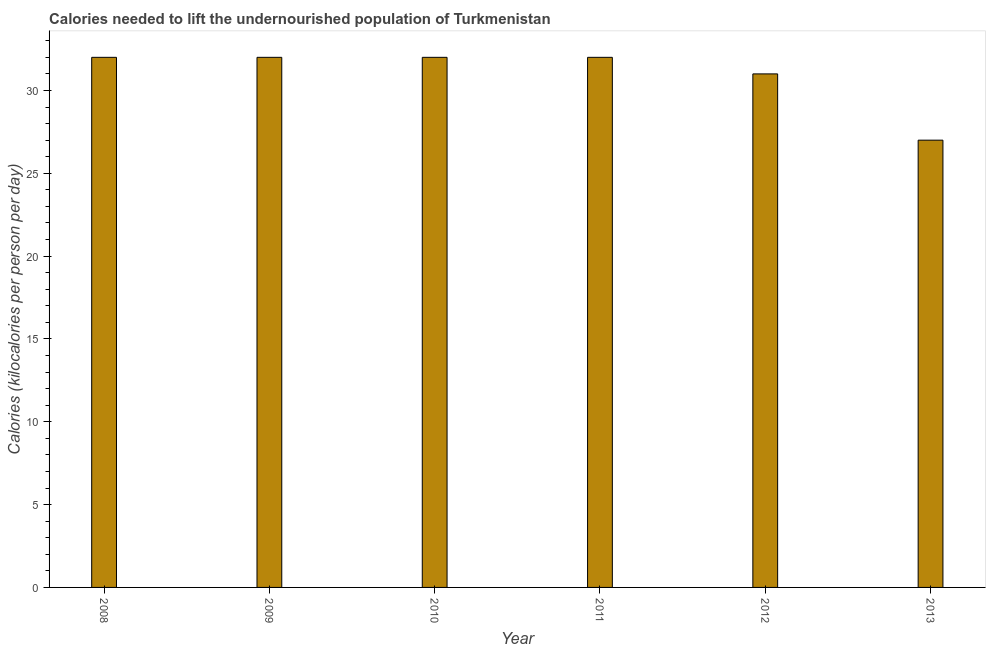Does the graph contain any zero values?
Ensure brevity in your answer.  No. What is the title of the graph?
Keep it short and to the point. Calories needed to lift the undernourished population of Turkmenistan. What is the label or title of the X-axis?
Give a very brief answer. Year. What is the label or title of the Y-axis?
Your answer should be compact. Calories (kilocalories per person per day). Across all years, what is the minimum depth of food deficit?
Your answer should be compact. 27. What is the sum of the depth of food deficit?
Offer a terse response. 186. What is the difference between the depth of food deficit in 2010 and 2011?
Your answer should be very brief. 0. What is the average depth of food deficit per year?
Keep it short and to the point. 31. Do a majority of the years between 2011 and 2012 (inclusive) have depth of food deficit greater than 4 kilocalories?
Your response must be concise. Yes. What is the ratio of the depth of food deficit in 2011 to that in 2012?
Your response must be concise. 1.03. Is the depth of food deficit in 2009 less than that in 2012?
Make the answer very short. No. In how many years, is the depth of food deficit greater than the average depth of food deficit taken over all years?
Your answer should be compact. 4. How many bars are there?
Offer a very short reply. 6. Are all the bars in the graph horizontal?
Provide a succinct answer. No. How many years are there in the graph?
Your response must be concise. 6. What is the difference between the Calories (kilocalories per person per day) in 2008 and 2009?
Ensure brevity in your answer.  0. What is the difference between the Calories (kilocalories per person per day) in 2008 and 2010?
Your answer should be compact. 0. What is the difference between the Calories (kilocalories per person per day) in 2008 and 2011?
Provide a succinct answer. 0. What is the difference between the Calories (kilocalories per person per day) in 2009 and 2010?
Ensure brevity in your answer.  0. What is the difference between the Calories (kilocalories per person per day) in 2009 and 2011?
Keep it short and to the point. 0. What is the difference between the Calories (kilocalories per person per day) in 2009 and 2012?
Offer a terse response. 1. What is the difference between the Calories (kilocalories per person per day) in 2009 and 2013?
Provide a succinct answer. 5. What is the difference between the Calories (kilocalories per person per day) in 2010 and 2011?
Your answer should be compact. 0. What is the difference between the Calories (kilocalories per person per day) in 2010 and 2012?
Provide a short and direct response. 1. What is the difference between the Calories (kilocalories per person per day) in 2011 and 2012?
Your answer should be very brief. 1. What is the difference between the Calories (kilocalories per person per day) in 2012 and 2013?
Your answer should be very brief. 4. What is the ratio of the Calories (kilocalories per person per day) in 2008 to that in 2009?
Keep it short and to the point. 1. What is the ratio of the Calories (kilocalories per person per day) in 2008 to that in 2012?
Provide a succinct answer. 1.03. What is the ratio of the Calories (kilocalories per person per day) in 2008 to that in 2013?
Provide a succinct answer. 1.19. What is the ratio of the Calories (kilocalories per person per day) in 2009 to that in 2010?
Ensure brevity in your answer.  1. What is the ratio of the Calories (kilocalories per person per day) in 2009 to that in 2011?
Give a very brief answer. 1. What is the ratio of the Calories (kilocalories per person per day) in 2009 to that in 2012?
Offer a terse response. 1.03. What is the ratio of the Calories (kilocalories per person per day) in 2009 to that in 2013?
Make the answer very short. 1.19. What is the ratio of the Calories (kilocalories per person per day) in 2010 to that in 2011?
Your response must be concise. 1. What is the ratio of the Calories (kilocalories per person per day) in 2010 to that in 2012?
Your answer should be compact. 1.03. What is the ratio of the Calories (kilocalories per person per day) in 2010 to that in 2013?
Ensure brevity in your answer.  1.19. What is the ratio of the Calories (kilocalories per person per day) in 2011 to that in 2012?
Offer a very short reply. 1.03. What is the ratio of the Calories (kilocalories per person per day) in 2011 to that in 2013?
Your answer should be compact. 1.19. What is the ratio of the Calories (kilocalories per person per day) in 2012 to that in 2013?
Offer a terse response. 1.15. 